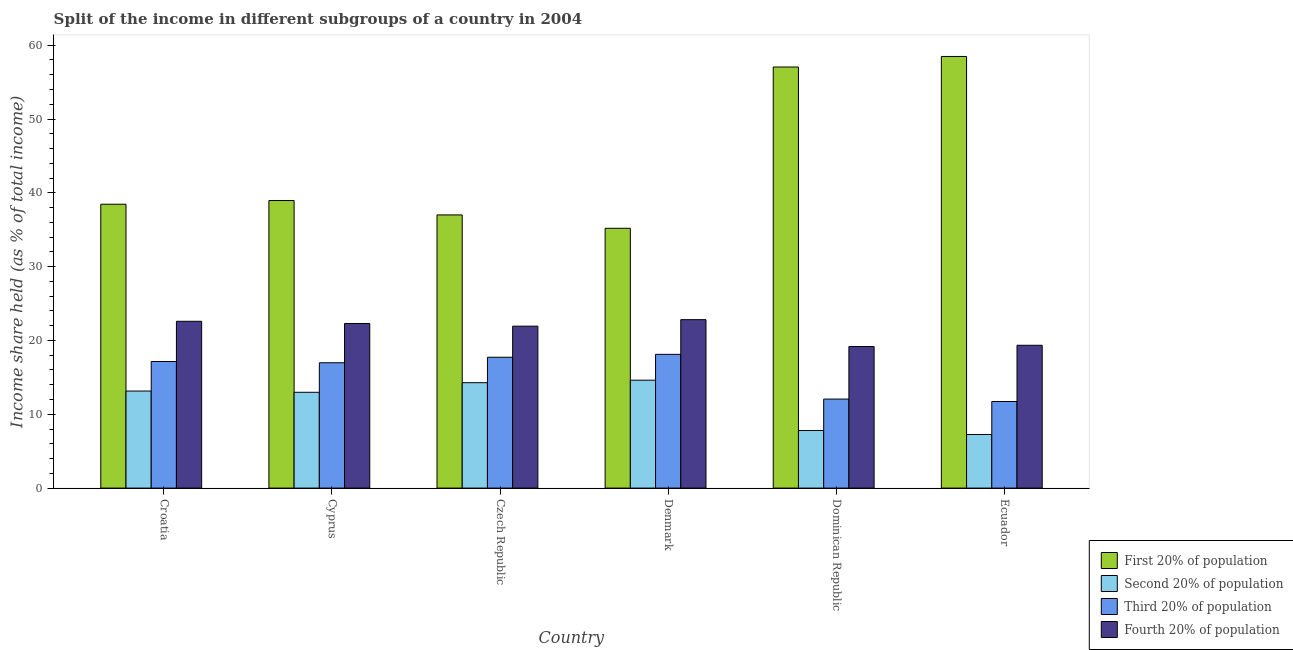How many different coloured bars are there?
Provide a short and direct response. 4. Are the number of bars on each tick of the X-axis equal?
Give a very brief answer. Yes. How many bars are there on the 1st tick from the left?
Make the answer very short. 4. What is the label of the 5th group of bars from the left?
Offer a terse response. Dominican Republic. In how many cases, is the number of bars for a given country not equal to the number of legend labels?
Give a very brief answer. 0. What is the share of the income held by fourth 20% of the population in Dominican Republic?
Ensure brevity in your answer.  19.18. Across all countries, what is the maximum share of the income held by first 20% of the population?
Offer a very short reply. 58.48. Across all countries, what is the minimum share of the income held by fourth 20% of the population?
Keep it short and to the point. 19.18. In which country was the share of the income held by second 20% of the population minimum?
Keep it short and to the point. Ecuador. What is the total share of the income held by second 20% of the population in the graph?
Offer a terse response. 70.09. What is the difference between the share of the income held by third 20% of the population in Denmark and the share of the income held by second 20% of the population in Ecuador?
Offer a very short reply. 10.86. What is the average share of the income held by third 20% of the population per country?
Keep it short and to the point. 15.63. What is the difference between the share of the income held by third 20% of the population and share of the income held by first 20% of the population in Denmark?
Ensure brevity in your answer.  -17.08. What is the ratio of the share of the income held by second 20% of the population in Dominican Republic to that in Ecuador?
Make the answer very short. 1.07. Is the share of the income held by second 20% of the population in Croatia less than that in Dominican Republic?
Provide a short and direct response. No. Is the difference between the share of the income held by third 20% of the population in Cyprus and Denmark greater than the difference between the share of the income held by second 20% of the population in Cyprus and Denmark?
Offer a very short reply. Yes. What is the difference between the highest and the second highest share of the income held by second 20% of the population?
Provide a short and direct response. 0.34. What is the difference between the highest and the lowest share of the income held by first 20% of the population?
Your response must be concise. 23.28. Is the sum of the share of the income held by second 20% of the population in Czech Republic and Dominican Republic greater than the maximum share of the income held by fourth 20% of the population across all countries?
Your answer should be very brief. No. What does the 3rd bar from the left in Croatia represents?
Ensure brevity in your answer.  Third 20% of population. What does the 2nd bar from the right in Dominican Republic represents?
Your answer should be compact. Third 20% of population. Is it the case that in every country, the sum of the share of the income held by first 20% of the population and share of the income held by second 20% of the population is greater than the share of the income held by third 20% of the population?
Your response must be concise. Yes. How many bars are there?
Your answer should be compact. 24. Are all the bars in the graph horizontal?
Make the answer very short. No. How many countries are there in the graph?
Make the answer very short. 6. What is the difference between two consecutive major ticks on the Y-axis?
Your response must be concise. 10. Are the values on the major ticks of Y-axis written in scientific E-notation?
Provide a succinct answer. No. Does the graph contain any zero values?
Ensure brevity in your answer.  No. Where does the legend appear in the graph?
Give a very brief answer. Bottom right. How many legend labels are there?
Make the answer very short. 4. What is the title of the graph?
Provide a short and direct response. Split of the income in different subgroups of a country in 2004. What is the label or title of the Y-axis?
Your response must be concise. Income share held (as % of total income). What is the Income share held (as % of total income) in First 20% of population in Croatia?
Make the answer very short. 38.46. What is the Income share held (as % of total income) in Second 20% of population in Croatia?
Ensure brevity in your answer.  13.15. What is the Income share held (as % of total income) of Third 20% of population in Croatia?
Offer a terse response. 17.15. What is the Income share held (as % of total income) in Fourth 20% of population in Croatia?
Make the answer very short. 22.6. What is the Income share held (as % of total income) in First 20% of population in Cyprus?
Your answer should be very brief. 38.96. What is the Income share held (as % of total income) in Second 20% of population in Cyprus?
Make the answer very short. 12.98. What is the Income share held (as % of total income) in Third 20% of population in Cyprus?
Keep it short and to the point. 16.98. What is the Income share held (as % of total income) of Fourth 20% of population in Cyprus?
Provide a short and direct response. 22.3. What is the Income share held (as % of total income) of First 20% of population in Czech Republic?
Make the answer very short. 37.01. What is the Income share held (as % of total income) in Second 20% of population in Czech Republic?
Provide a short and direct response. 14.28. What is the Income share held (as % of total income) of Third 20% of population in Czech Republic?
Keep it short and to the point. 17.73. What is the Income share held (as % of total income) of Fourth 20% of population in Czech Republic?
Keep it short and to the point. 21.94. What is the Income share held (as % of total income) of First 20% of population in Denmark?
Ensure brevity in your answer.  35.2. What is the Income share held (as % of total income) in Second 20% of population in Denmark?
Make the answer very short. 14.62. What is the Income share held (as % of total income) in Third 20% of population in Denmark?
Provide a short and direct response. 18.12. What is the Income share held (as % of total income) of Fourth 20% of population in Denmark?
Give a very brief answer. 22.82. What is the Income share held (as % of total income) of First 20% of population in Dominican Republic?
Your answer should be very brief. 57.05. What is the Income share held (as % of total income) of Second 20% of population in Dominican Republic?
Give a very brief answer. 7.8. What is the Income share held (as % of total income) in Third 20% of population in Dominican Republic?
Provide a succinct answer. 12.06. What is the Income share held (as % of total income) in Fourth 20% of population in Dominican Republic?
Your answer should be very brief. 19.18. What is the Income share held (as % of total income) in First 20% of population in Ecuador?
Provide a succinct answer. 58.48. What is the Income share held (as % of total income) of Second 20% of population in Ecuador?
Offer a terse response. 7.26. What is the Income share held (as % of total income) in Third 20% of population in Ecuador?
Give a very brief answer. 11.73. What is the Income share held (as % of total income) of Fourth 20% of population in Ecuador?
Offer a very short reply. 19.35. Across all countries, what is the maximum Income share held (as % of total income) of First 20% of population?
Ensure brevity in your answer.  58.48. Across all countries, what is the maximum Income share held (as % of total income) of Second 20% of population?
Offer a terse response. 14.62. Across all countries, what is the maximum Income share held (as % of total income) of Third 20% of population?
Provide a succinct answer. 18.12. Across all countries, what is the maximum Income share held (as % of total income) in Fourth 20% of population?
Give a very brief answer. 22.82. Across all countries, what is the minimum Income share held (as % of total income) of First 20% of population?
Your response must be concise. 35.2. Across all countries, what is the minimum Income share held (as % of total income) of Second 20% of population?
Ensure brevity in your answer.  7.26. Across all countries, what is the minimum Income share held (as % of total income) of Third 20% of population?
Provide a succinct answer. 11.73. Across all countries, what is the minimum Income share held (as % of total income) of Fourth 20% of population?
Give a very brief answer. 19.18. What is the total Income share held (as % of total income) in First 20% of population in the graph?
Your response must be concise. 265.16. What is the total Income share held (as % of total income) of Second 20% of population in the graph?
Make the answer very short. 70.09. What is the total Income share held (as % of total income) of Third 20% of population in the graph?
Your answer should be very brief. 93.77. What is the total Income share held (as % of total income) of Fourth 20% of population in the graph?
Keep it short and to the point. 128.19. What is the difference between the Income share held (as % of total income) in Second 20% of population in Croatia and that in Cyprus?
Offer a very short reply. 0.17. What is the difference between the Income share held (as % of total income) in Third 20% of population in Croatia and that in Cyprus?
Your answer should be compact. 0.17. What is the difference between the Income share held (as % of total income) of Fourth 20% of population in Croatia and that in Cyprus?
Keep it short and to the point. 0.3. What is the difference between the Income share held (as % of total income) of First 20% of population in Croatia and that in Czech Republic?
Give a very brief answer. 1.45. What is the difference between the Income share held (as % of total income) in Second 20% of population in Croatia and that in Czech Republic?
Offer a very short reply. -1.13. What is the difference between the Income share held (as % of total income) in Third 20% of population in Croatia and that in Czech Republic?
Provide a short and direct response. -0.58. What is the difference between the Income share held (as % of total income) of Fourth 20% of population in Croatia and that in Czech Republic?
Make the answer very short. 0.66. What is the difference between the Income share held (as % of total income) of First 20% of population in Croatia and that in Denmark?
Ensure brevity in your answer.  3.26. What is the difference between the Income share held (as % of total income) in Second 20% of population in Croatia and that in Denmark?
Keep it short and to the point. -1.47. What is the difference between the Income share held (as % of total income) of Third 20% of population in Croatia and that in Denmark?
Keep it short and to the point. -0.97. What is the difference between the Income share held (as % of total income) in Fourth 20% of population in Croatia and that in Denmark?
Your answer should be compact. -0.22. What is the difference between the Income share held (as % of total income) in First 20% of population in Croatia and that in Dominican Republic?
Ensure brevity in your answer.  -18.59. What is the difference between the Income share held (as % of total income) in Second 20% of population in Croatia and that in Dominican Republic?
Offer a terse response. 5.35. What is the difference between the Income share held (as % of total income) in Third 20% of population in Croatia and that in Dominican Republic?
Make the answer very short. 5.09. What is the difference between the Income share held (as % of total income) of Fourth 20% of population in Croatia and that in Dominican Republic?
Ensure brevity in your answer.  3.42. What is the difference between the Income share held (as % of total income) of First 20% of population in Croatia and that in Ecuador?
Keep it short and to the point. -20.02. What is the difference between the Income share held (as % of total income) in Second 20% of population in Croatia and that in Ecuador?
Make the answer very short. 5.89. What is the difference between the Income share held (as % of total income) of Third 20% of population in Croatia and that in Ecuador?
Ensure brevity in your answer.  5.42. What is the difference between the Income share held (as % of total income) in First 20% of population in Cyprus and that in Czech Republic?
Your answer should be compact. 1.95. What is the difference between the Income share held (as % of total income) in Third 20% of population in Cyprus and that in Czech Republic?
Your answer should be compact. -0.75. What is the difference between the Income share held (as % of total income) in Fourth 20% of population in Cyprus and that in Czech Republic?
Provide a short and direct response. 0.36. What is the difference between the Income share held (as % of total income) in First 20% of population in Cyprus and that in Denmark?
Offer a very short reply. 3.76. What is the difference between the Income share held (as % of total income) in Second 20% of population in Cyprus and that in Denmark?
Your answer should be compact. -1.64. What is the difference between the Income share held (as % of total income) of Third 20% of population in Cyprus and that in Denmark?
Offer a terse response. -1.14. What is the difference between the Income share held (as % of total income) in Fourth 20% of population in Cyprus and that in Denmark?
Make the answer very short. -0.52. What is the difference between the Income share held (as % of total income) in First 20% of population in Cyprus and that in Dominican Republic?
Make the answer very short. -18.09. What is the difference between the Income share held (as % of total income) of Second 20% of population in Cyprus and that in Dominican Republic?
Ensure brevity in your answer.  5.18. What is the difference between the Income share held (as % of total income) in Third 20% of population in Cyprus and that in Dominican Republic?
Give a very brief answer. 4.92. What is the difference between the Income share held (as % of total income) in Fourth 20% of population in Cyprus and that in Dominican Republic?
Provide a short and direct response. 3.12. What is the difference between the Income share held (as % of total income) in First 20% of population in Cyprus and that in Ecuador?
Ensure brevity in your answer.  -19.52. What is the difference between the Income share held (as % of total income) in Second 20% of population in Cyprus and that in Ecuador?
Offer a terse response. 5.72. What is the difference between the Income share held (as % of total income) of Third 20% of population in Cyprus and that in Ecuador?
Give a very brief answer. 5.25. What is the difference between the Income share held (as % of total income) of Fourth 20% of population in Cyprus and that in Ecuador?
Make the answer very short. 2.95. What is the difference between the Income share held (as % of total income) in First 20% of population in Czech Republic and that in Denmark?
Provide a short and direct response. 1.81. What is the difference between the Income share held (as % of total income) in Second 20% of population in Czech Republic and that in Denmark?
Give a very brief answer. -0.34. What is the difference between the Income share held (as % of total income) in Third 20% of population in Czech Republic and that in Denmark?
Your answer should be very brief. -0.39. What is the difference between the Income share held (as % of total income) in Fourth 20% of population in Czech Republic and that in Denmark?
Offer a very short reply. -0.88. What is the difference between the Income share held (as % of total income) in First 20% of population in Czech Republic and that in Dominican Republic?
Make the answer very short. -20.04. What is the difference between the Income share held (as % of total income) of Second 20% of population in Czech Republic and that in Dominican Republic?
Your answer should be compact. 6.48. What is the difference between the Income share held (as % of total income) of Third 20% of population in Czech Republic and that in Dominican Republic?
Your answer should be very brief. 5.67. What is the difference between the Income share held (as % of total income) in Fourth 20% of population in Czech Republic and that in Dominican Republic?
Your response must be concise. 2.76. What is the difference between the Income share held (as % of total income) of First 20% of population in Czech Republic and that in Ecuador?
Provide a succinct answer. -21.47. What is the difference between the Income share held (as % of total income) in Second 20% of population in Czech Republic and that in Ecuador?
Make the answer very short. 7.02. What is the difference between the Income share held (as % of total income) in Fourth 20% of population in Czech Republic and that in Ecuador?
Provide a short and direct response. 2.59. What is the difference between the Income share held (as % of total income) of First 20% of population in Denmark and that in Dominican Republic?
Your answer should be compact. -21.85. What is the difference between the Income share held (as % of total income) of Second 20% of population in Denmark and that in Dominican Republic?
Your response must be concise. 6.82. What is the difference between the Income share held (as % of total income) in Third 20% of population in Denmark and that in Dominican Republic?
Keep it short and to the point. 6.06. What is the difference between the Income share held (as % of total income) in Fourth 20% of population in Denmark and that in Dominican Republic?
Provide a short and direct response. 3.64. What is the difference between the Income share held (as % of total income) of First 20% of population in Denmark and that in Ecuador?
Provide a succinct answer. -23.28. What is the difference between the Income share held (as % of total income) of Second 20% of population in Denmark and that in Ecuador?
Give a very brief answer. 7.36. What is the difference between the Income share held (as % of total income) of Third 20% of population in Denmark and that in Ecuador?
Your response must be concise. 6.39. What is the difference between the Income share held (as % of total income) of Fourth 20% of population in Denmark and that in Ecuador?
Provide a succinct answer. 3.47. What is the difference between the Income share held (as % of total income) in First 20% of population in Dominican Republic and that in Ecuador?
Your answer should be compact. -1.43. What is the difference between the Income share held (as % of total income) of Second 20% of population in Dominican Republic and that in Ecuador?
Your response must be concise. 0.54. What is the difference between the Income share held (as % of total income) in Third 20% of population in Dominican Republic and that in Ecuador?
Ensure brevity in your answer.  0.33. What is the difference between the Income share held (as % of total income) in Fourth 20% of population in Dominican Republic and that in Ecuador?
Provide a short and direct response. -0.17. What is the difference between the Income share held (as % of total income) in First 20% of population in Croatia and the Income share held (as % of total income) in Second 20% of population in Cyprus?
Keep it short and to the point. 25.48. What is the difference between the Income share held (as % of total income) in First 20% of population in Croatia and the Income share held (as % of total income) in Third 20% of population in Cyprus?
Your answer should be very brief. 21.48. What is the difference between the Income share held (as % of total income) of First 20% of population in Croatia and the Income share held (as % of total income) of Fourth 20% of population in Cyprus?
Your answer should be compact. 16.16. What is the difference between the Income share held (as % of total income) of Second 20% of population in Croatia and the Income share held (as % of total income) of Third 20% of population in Cyprus?
Provide a succinct answer. -3.83. What is the difference between the Income share held (as % of total income) of Second 20% of population in Croatia and the Income share held (as % of total income) of Fourth 20% of population in Cyprus?
Provide a succinct answer. -9.15. What is the difference between the Income share held (as % of total income) of Third 20% of population in Croatia and the Income share held (as % of total income) of Fourth 20% of population in Cyprus?
Your answer should be very brief. -5.15. What is the difference between the Income share held (as % of total income) in First 20% of population in Croatia and the Income share held (as % of total income) in Second 20% of population in Czech Republic?
Offer a very short reply. 24.18. What is the difference between the Income share held (as % of total income) of First 20% of population in Croatia and the Income share held (as % of total income) of Third 20% of population in Czech Republic?
Your answer should be compact. 20.73. What is the difference between the Income share held (as % of total income) in First 20% of population in Croatia and the Income share held (as % of total income) in Fourth 20% of population in Czech Republic?
Make the answer very short. 16.52. What is the difference between the Income share held (as % of total income) in Second 20% of population in Croatia and the Income share held (as % of total income) in Third 20% of population in Czech Republic?
Keep it short and to the point. -4.58. What is the difference between the Income share held (as % of total income) in Second 20% of population in Croatia and the Income share held (as % of total income) in Fourth 20% of population in Czech Republic?
Offer a very short reply. -8.79. What is the difference between the Income share held (as % of total income) of Third 20% of population in Croatia and the Income share held (as % of total income) of Fourth 20% of population in Czech Republic?
Ensure brevity in your answer.  -4.79. What is the difference between the Income share held (as % of total income) of First 20% of population in Croatia and the Income share held (as % of total income) of Second 20% of population in Denmark?
Make the answer very short. 23.84. What is the difference between the Income share held (as % of total income) of First 20% of population in Croatia and the Income share held (as % of total income) of Third 20% of population in Denmark?
Your answer should be very brief. 20.34. What is the difference between the Income share held (as % of total income) in First 20% of population in Croatia and the Income share held (as % of total income) in Fourth 20% of population in Denmark?
Ensure brevity in your answer.  15.64. What is the difference between the Income share held (as % of total income) of Second 20% of population in Croatia and the Income share held (as % of total income) of Third 20% of population in Denmark?
Provide a short and direct response. -4.97. What is the difference between the Income share held (as % of total income) of Second 20% of population in Croatia and the Income share held (as % of total income) of Fourth 20% of population in Denmark?
Your answer should be compact. -9.67. What is the difference between the Income share held (as % of total income) in Third 20% of population in Croatia and the Income share held (as % of total income) in Fourth 20% of population in Denmark?
Your answer should be compact. -5.67. What is the difference between the Income share held (as % of total income) in First 20% of population in Croatia and the Income share held (as % of total income) in Second 20% of population in Dominican Republic?
Provide a short and direct response. 30.66. What is the difference between the Income share held (as % of total income) of First 20% of population in Croatia and the Income share held (as % of total income) of Third 20% of population in Dominican Republic?
Offer a terse response. 26.4. What is the difference between the Income share held (as % of total income) of First 20% of population in Croatia and the Income share held (as % of total income) of Fourth 20% of population in Dominican Republic?
Give a very brief answer. 19.28. What is the difference between the Income share held (as % of total income) in Second 20% of population in Croatia and the Income share held (as % of total income) in Third 20% of population in Dominican Republic?
Your answer should be very brief. 1.09. What is the difference between the Income share held (as % of total income) in Second 20% of population in Croatia and the Income share held (as % of total income) in Fourth 20% of population in Dominican Republic?
Keep it short and to the point. -6.03. What is the difference between the Income share held (as % of total income) of Third 20% of population in Croatia and the Income share held (as % of total income) of Fourth 20% of population in Dominican Republic?
Make the answer very short. -2.03. What is the difference between the Income share held (as % of total income) of First 20% of population in Croatia and the Income share held (as % of total income) of Second 20% of population in Ecuador?
Make the answer very short. 31.2. What is the difference between the Income share held (as % of total income) of First 20% of population in Croatia and the Income share held (as % of total income) of Third 20% of population in Ecuador?
Your answer should be compact. 26.73. What is the difference between the Income share held (as % of total income) in First 20% of population in Croatia and the Income share held (as % of total income) in Fourth 20% of population in Ecuador?
Your answer should be very brief. 19.11. What is the difference between the Income share held (as % of total income) of Second 20% of population in Croatia and the Income share held (as % of total income) of Third 20% of population in Ecuador?
Make the answer very short. 1.42. What is the difference between the Income share held (as % of total income) of Second 20% of population in Croatia and the Income share held (as % of total income) of Fourth 20% of population in Ecuador?
Provide a succinct answer. -6.2. What is the difference between the Income share held (as % of total income) in Third 20% of population in Croatia and the Income share held (as % of total income) in Fourth 20% of population in Ecuador?
Provide a short and direct response. -2.2. What is the difference between the Income share held (as % of total income) in First 20% of population in Cyprus and the Income share held (as % of total income) in Second 20% of population in Czech Republic?
Offer a terse response. 24.68. What is the difference between the Income share held (as % of total income) of First 20% of population in Cyprus and the Income share held (as % of total income) of Third 20% of population in Czech Republic?
Offer a very short reply. 21.23. What is the difference between the Income share held (as % of total income) in First 20% of population in Cyprus and the Income share held (as % of total income) in Fourth 20% of population in Czech Republic?
Provide a short and direct response. 17.02. What is the difference between the Income share held (as % of total income) in Second 20% of population in Cyprus and the Income share held (as % of total income) in Third 20% of population in Czech Republic?
Ensure brevity in your answer.  -4.75. What is the difference between the Income share held (as % of total income) of Second 20% of population in Cyprus and the Income share held (as % of total income) of Fourth 20% of population in Czech Republic?
Ensure brevity in your answer.  -8.96. What is the difference between the Income share held (as % of total income) in Third 20% of population in Cyprus and the Income share held (as % of total income) in Fourth 20% of population in Czech Republic?
Provide a short and direct response. -4.96. What is the difference between the Income share held (as % of total income) in First 20% of population in Cyprus and the Income share held (as % of total income) in Second 20% of population in Denmark?
Ensure brevity in your answer.  24.34. What is the difference between the Income share held (as % of total income) of First 20% of population in Cyprus and the Income share held (as % of total income) of Third 20% of population in Denmark?
Provide a short and direct response. 20.84. What is the difference between the Income share held (as % of total income) in First 20% of population in Cyprus and the Income share held (as % of total income) in Fourth 20% of population in Denmark?
Keep it short and to the point. 16.14. What is the difference between the Income share held (as % of total income) of Second 20% of population in Cyprus and the Income share held (as % of total income) of Third 20% of population in Denmark?
Offer a very short reply. -5.14. What is the difference between the Income share held (as % of total income) of Second 20% of population in Cyprus and the Income share held (as % of total income) of Fourth 20% of population in Denmark?
Offer a terse response. -9.84. What is the difference between the Income share held (as % of total income) in Third 20% of population in Cyprus and the Income share held (as % of total income) in Fourth 20% of population in Denmark?
Your answer should be compact. -5.84. What is the difference between the Income share held (as % of total income) of First 20% of population in Cyprus and the Income share held (as % of total income) of Second 20% of population in Dominican Republic?
Your response must be concise. 31.16. What is the difference between the Income share held (as % of total income) of First 20% of population in Cyprus and the Income share held (as % of total income) of Third 20% of population in Dominican Republic?
Offer a very short reply. 26.9. What is the difference between the Income share held (as % of total income) in First 20% of population in Cyprus and the Income share held (as % of total income) in Fourth 20% of population in Dominican Republic?
Provide a succinct answer. 19.78. What is the difference between the Income share held (as % of total income) in Third 20% of population in Cyprus and the Income share held (as % of total income) in Fourth 20% of population in Dominican Republic?
Your response must be concise. -2.2. What is the difference between the Income share held (as % of total income) in First 20% of population in Cyprus and the Income share held (as % of total income) in Second 20% of population in Ecuador?
Your response must be concise. 31.7. What is the difference between the Income share held (as % of total income) in First 20% of population in Cyprus and the Income share held (as % of total income) in Third 20% of population in Ecuador?
Keep it short and to the point. 27.23. What is the difference between the Income share held (as % of total income) in First 20% of population in Cyprus and the Income share held (as % of total income) in Fourth 20% of population in Ecuador?
Ensure brevity in your answer.  19.61. What is the difference between the Income share held (as % of total income) in Second 20% of population in Cyprus and the Income share held (as % of total income) in Third 20% of population in Ecuador?
Keep it short and to the point. 1.25. What is the difference between the Income share held (as % of total income) in Second 20% of population in Cyprus and the Income share held (as % of total income) in Fourth 20% of population in Ecuador?
Provide a succinct answer. -6.37. What is the difference between the Income share held (as % of total income) of Third 20% of population in Cyprus and the Income share held (as % of total income) of Fourth 20% of population in Ecuador?
Give a very brief answer. -2.37. What is the difference between the Income share held (as % of total income) of First 20% of population in Czech Republic and the Income share held (as % of total income) of Second 20% of population in Denmark?
Offer a very short reply. 22.39. What is the difference between the Income share held (as % of total income) in First 20% of population in Czech Republic and the Income share held (as % of total income) in Third 20% of population in Denmark?
Make the answer very short. 18.89. What is the difference between the Income share held (as % of total income) of First 20% of population in Czech Republic and the Income share held (as % of total income) of Fourth 20% of population in Denmark?
Provide a succinct answer. 14.19. What is the difference between the Income share held (as % of total income) in Second 20% of population in Czech Republic and the Income share held (as % of total income) in Third 20% of population in Denmark?
Your answer should be compact. -3.84. What is the difference between the Income share held (as % of total income) in Second 20% of population in Czech Republic and the Income share held (as % of total income) in Fourth 20% of population in Denmark?
Offer a very short reply. -8.54. What is the difference between the Income share held (as % of total income) of Third 20% of population in Czech Republic and the Income share held (as % of total income) of Fourth 20% of population in Denmark?
Your answer should be compact. -5.09. What is the difference between the Income share held (as % of total income) of First 20% of population in Czech Republic and the Income share held (as % of total income) of Second 20% of population in Dominican Republic?
Make the answer very short. 29.21. What is the difference between the Income share held (as % of total income) in First 20% of population in Czech Republic and the Income share held (as % of total income) in Third 20% of population in Dominican Republic?
Keep it short and to the point. 24.95. What is the difference between the Income share held (as % of total income) of First 20% of population in Czech Republic and the Income share held (as % of total income) of Fourth 20% of population in Dominican Republic?
Keep it short and to the point. 17.83. What is the difference between the Income share held (as % of total income) in Second 20% of population in Czech Republic and the Income share held (as % of total income) in Third 20% of population in Dominican Republic?
Make the answer very short. 2.22. What is the difference between the Income share held (as % of total income) of Third 20% of population in Czech Republic and the Income share held (as % of total income) of Fourth 20% of population in Dominican Republic?
Offer a very short reply. -1.45. What is the difference between the Income share held (as % of total income) of First 20% of population in Czech Republic and the Income share held (as % of total income) of Second 20% of population in Ecuador?
Your answer should be very brief. 29.75. What is the difference between the Income share held (as % of total income) in First 20% of population in Czech Republic and the Income share held (as % of total income) in Third 20% of population in Ecuador?
Offer a terse response. 25.28. What is the difference between the Income share held (as % of total income) in First 20% of population in Czech Republic and the Income share held (as % of total income) in Fourth 20% of population in Ecuador?
Ensure brevity in your answer.  17.66. What is the difference between the Income share held (as % of total income) of Second 20% of population in Czech Republic and the Income share held (as % of total income) of Third 20% of population in Ecuador?
Ensure brevity in your answer.  2.55. What is the difference between the Income share held (as % of total income) in Second 20% of population in Czech Republic and the Income share held (as % of total income) in Fourth 20% of population in Ecuador?
Give a very brief answer. -5.07. What is the difference between the Income share held (as % of total income) of Third 20% of population in Czech Republic and the Income share held (as % of total income) of Fourth 20% of population in Ecuador?
Offer a terse response. -1.62. What is the difference between the Income share held (as % of total income) of First 20% of population in Denmark and the Income share held (as % of total income) of Second 20% of population in Dominican Republic?
Make the answer very short. 27.4. What is the difference between the Income share held (as % of total income) in First 20% of population in Denmark and the Income share held (as % of total income) in Third 20% of population in Dominican Republic?
Your response must be concise. 23.14. What is the difference between the Income share held (as % of total income) of First 20% of population in Denmark and the Income share held (as % of total income) of Fourth 20% of population in Dominican Republic?
Keep it short and to the point. 16.02. What is the difference between the Income share held (as % of total income) in Second 20% of population in Denmark and the Income share held (as % of total income) in Third 20% of population in Dominican Republic?
Your answer should be compact. 2.56. What is the difference between the Income share held (as % of total income) in Second 20% of population in Denmark and the Income share held (as % of total income) in Fourth 20% of population in Dominican Republic?
Provide a succinct answer. -4.56. What is the difference between the Income share held (as % of total income) of Third 20% of population in Denmark and the Income share held (as % of total income) of Fourth 20% of population in Dominican Republic?
Offer a very short reply. -1.06. What is the difference between the Income share held (as % of total income) of First 20% of population in Denmark and the Income share held (as % of total income) of Second 20% of population in Ecuador?
Make the answer very short. 27.94. What is the difference between the Income share held (as % of total income) in First 20% of population in Denmark and the Income share held (as % of total income) in Third 20% of population in Ecuador?
Offer a very short reply. 23.47. What is the difference between the Income share held (as % of total income) in First 20% of population in Denmark and the Income share held (as % of total income) in Fourth 20% of population in Ecuador?
Keep it short and to the point. 15.85. What is the difference between the Income share held (as % of total income) in Second 20% of population in Denmark and the Income share held (as % of total income) in Third 20% of population in Ecuador?
Make the answer very short. 2.89. What is the difference between the Income share held (as % of total income) in Second 20% of population in Denmark and the Income share held (as % of total income) in Fourth 20% of population in Ecuador?
Offer a terse response. -4.73. What is the difference between the Income share held (as % of total income) of Third 20% of population in Denmark and the Income share held (as % of total income) of Fourth 20% of population in Ecuador?
Your answer should be compact. -1.23. What is the difference between the Income share held (as % of total income) in First 20% of population in Dominican Republic and the Income share held (as % of total income) in Second 20% of population in Ecuador?
Give a very brief answer. 49.79. What is the difference between the Income share held (as % of total income) of First 20% of population in Dominican Republic and the Income share held (as % of total income) of Third 20% of population in Ecuador?
Your answer should be very brief. 45.32. What is the difference between the Income share held (as % of total income) in First 20% of population in Dominican Republic and the Income share held (as % of total income) in Fourth 20% of population in Ecuador?
Give a very brief answer. 37.7. What is the difference between the Income share held (as % of total income) in Second 20% of population in Dominican Republic and the Income share held (as % of total income) in Third 20% of population in Ecuador?
Make the answer very short. -3.93. What is the difference between the Income share held (as % of total income) in Second 20% of population in Dominican Republic and the Income share held (as % of total income) in Fourth 20% of population in Ecuador?
Your answer should be very brief. -11.55. What is the difference between the Income share held (as % of total income) of Third 20% of population in Dominican Republic and the Income share held (as % of total income) of Fourth 20% of population in Ecuador?
Provide a succinct answer. -7.29. What is the average Income share held (as % of total income) of First 20% of population per country?
Offer a terse response. 44.19. What is the average Income share held (as % of total income) in Second 20% of population per country?
Offer a very short reply. 11.68. What is the average Income share held (as % of total income) of Third 20% of population per country?
Your answer should be compact. 15.63. What is the average Income share held (as % of total income) of Fourth 20% of population per country?
Keep it short and to the point. 21.36. What is the difference between the Income share held (as % of total income) in First 20% of population and Income share held (as % of total income) in Second 20% of population in Croatia?
Provide a short and direct response. 25.31. What is the difference between the Income share held (as % of total income) of First 20% of population and Income share held (as % of total income) of Third 20% of population in Croatia?
Your answer should be compact. 21.31. What is the difference between the Income share held (as % of total income) in First 20% of population and Income share held (as % of total income) in Fourth 20% of population in Croatia?
Offer a very short reply. 15.86. What is the difference between the Income share held (as % of total income) in Second 20% of population and Income share held (as % of total income) in Fourth 20% of population in Croatia?
Keep it short and to the point. -9.45. What is the difference between the Income share held (as % of total income) in Third 20% of population and Income share held (as % of total income) in Fourth 20% of population in Croatia?
Your answer should be compact. -5.45. What is the difference between the Income share held (as % of total income) in First 20% of population and Income share held (as % of total income) in Second 20% of population in Cyprus?
Provide a succinct answer. 25.98. What is the difference between the Income share held (as % of total income) of First 20% of population and Income share held (as % of total income) of Third 20% of population in Cyprus?
Make the answer very short. 21.98. What is the difference between the Income share held (as % of total income) in First 20% of population and Income share held (as % of total income) in Fourth 20% of population in Cyprus?
Your response must be concise. 16.66. What is the difference between the Income share held (as % of total income) in Second 20% of population and Income share held (as % of total income) in Third 20% of population in Cyprus?
Give a very brief answer. -4. What is the difference between the Income share held (as % of total income) of Second 20% of population and Income share held (as % of total income) of Fourth 20% of population in Cyprus?
Provide a short and direct response. -9.32. What is the difference between the Income share held (as % of total income) in Third 20% of population and Income share held (as % of total income) in Fourth 20% of population in Cyprus?
Your answer should be very brief. -5.32. What is the difference between the Income share held (as % of total income) in First 20% of population and Income share held (as % of total income) in Second 20% of population in Czech Republic?
Your answer should be compact. 22.73. What is the difference between the Income share held (as % of total income) in First 20% of population and Income share held (as % of total income) in Third 20% of population in Czech Republic?
Keep it short and to the point. 19.28. What is the difference between the Income share held (as % of total income) in First 20% of population and Income share held (as % of total income) in Fourth 20% of population in Czech Republic?
Provide a short and direct response. 15.07. What is the difference between the Income share held (as % of total income) of Second 20% of population and Income share held (as % of total income) of Third 20% of population in Czech Republic?
Provide a short and direct response. -3.45. What is the difference between the Income share held (as % of total income) of Second 20% of population and Income share held (as % of total income) of Fourth 20% of population in Czech Republic?
Keep it short and to the point. -7.66. What is the difference between the Income share held (as % of total income) of Third 20% of population and Income share held (as % of total income) of Fourth 20% of population in Czech Republic?
Keep it short and to the point. -4.21. What is the difference between the Income share held (as % of total income) of First 20% of population and Income share held (as % of total income) of Second 20% of population in Denmark?
Provide a short and direct response. 20.58. What is the difference between the Income share held (as % of total income) of First 20% of population and Income share held (as % of total income) of Third 20% of population in Denmark?
Offer a terse response. 17.08. What is the difference between the Income share held (as % of total income) in First 20% of population and Income share held (as % of total income) in Fourth 20% of population in Denmark?
Your response must be concise. 12.38. What is the difference between the Income share held (as % of total income) in Second 20% of population and Income share held (as % of total income) in Third 20% of population in Denmark?
Your answer should be very brief. -3.5. What is the difference between the Income share held (as % of total income) in Second 20% of population and Income share held (as % of total income) in Fourth 20% of population in Denmark?
Provide a short and direct response. -8.2. What is the difference between the Income share held (as % of total income) in Third 20% of population and Income share held (as % of total income) in Fourth 20% of population in Denmark?
Offer a very short reply. -4.7. What is the difference between the Income share held (as % of total income) of First 20% of population and Income share held (as % of total income) of Second 20% of population in Dominican Republic?
Provide a succinct answer. 49.25. What is the difference between the Income share held (as % of total income) of First 20% of population and Income share held (as % of total income) of Third 20% of population in Dominican Republic?
Keep it short and to the point. 44.99. What is the difference between the Income share held (as % of total income) of First 20% of population and Income share held (as % of total income) of Fourth 20% of population in Dominican Republic?
Give a very brief answer. 37.87. What is the difference between the Income share held (as % of total income) of Second 20% of population and Income share held (as % of total income) of Third 20% of population in Dominican Republic?
Keep it short and to the point. -4.26. What is the difference between the Income share held (as % of total income) in Second 20% of population and Income share held (as % of total income) in Fourth 20% of population in Dominican Republic?
Make the answer very short. -11.38. What is the difference between the Income share held (as % of total income) of Third 20% of population and Income share held (as % of total income) of Fourth 20% of population in Dominican Republic?
Provide a succinct answer. -7.12. What is the difference between the Income share held (as % of total income) of First 20% of population and Income share held (as % of total income) of Second 20% of population in Ecuador?
Provide a short and direct response. 51.22. What is the difference between the Income share held (as % of total income) in First 20% of population and Income share held (as % of total income) in Third 20% of population in Ecuador?
Keep it short and to the point. 46.75. What is the difference between the Income share held (as % of total income) of First 20% of population and Income share held (as % of total income) of Fourth 20% of population in Ecuador?
Your answer should be compact. 39.13. What is the difference between the Income share held (as % of total income) of Second 20% of population and Income share held (as % of total income) of Third 20% of population in Ecuador?
Your response must be concise. -4.47. What is the difference between the Income share held (as % of total income) in Second 20% of population and Income share held (as % of total income) in Fourth 20% of population in Ecuador?
Your response must be concise. -12.09. What is the difference between the Income share held (as % of total income) in Third 20% of population and Income share held (as % of total income) in Fourth 20% of population in Ecuador?
Make the answer very short. -7.62. What is the ratio of the Income share held (as % of total income) in First 20% of population in Croatia to that in Cyprus?
Give a very brief answer. 0.99. What is the ratio of the Income share held (as % of total income) in Second 20% of population in Croatia to that in Cyprus?
Your response must be concise. 1.01. What is the ratio of the Income share held (as % of total income) of Third 20% of population in Croatia to that in Cyprus?
Keep it short and to the point. 1.01. What is the ratio of the Income share held (as % of total income) of Fourth 20% of population in Croatia to that in Cyprus?
Keep it short and to the point. 1.01. What is the ratio of the Income share held (as % of total income) of First 20% of population in Croatia to that in Czech Republic?
Give a very brief answer. 1.04. What is the ratio of the Income share held (as % of total income) in Second 20% of population in Croatia to that in Czech Republic?
Offer a very short reply. 0.92. What is the ratio of the Income share held (as % of total income) in Third 20% of population in Croatia to that in Czech Republic?
Offer a terse response. 0.97. What is the ratio of the Income share held (as % of total income) of Fourth 20% of population in Croatia to that in Czech Republic?
Provide a short and direct response. 1.03. What is the ratio of the Income share held (as % of total income) of First 20% of population in Croatia to that in Denmark?
Your answer should be compact. 1.09. What is the ratio of the Income share held (as % of total income) of Second 20% of population in Croatia to that in Denmark?
Provide a succinct answer. 0.9. What is the ratio of the Income share held (as % of total income) in Third 20% of population in Croatia to that in Denmark?
Your answer should be compact. 0.95. What is the ratio of the Income share held (as % of total income) in First 20% of population in Croatia to that in Dominican Republic?
Give a very brief answer. 0.67. What is the ratio of the Income share held (as % of total income) of Second 20% of population in Croatia to that in Dominican Republic?
Your answer should be very brief. 1.69. What is the ratio of the Income share held (as % of total income) in Third 20% of population in Croatia to that in Dominican Republic?
Provide a short and direct response. 1.42. What is the ratio of the Income share held (as % of total income) of Fourth 20% of population in Croatia to that in Dominican Republic?
Your answer should be very brief. 1.18. What is the ratio of the Income share held (as % of total income) in First 20% of population in Croatia to that in Ecuador?
Provide a short and direct response. 0.66. What is the ratio of the Income share held (as % of total income) of Second 20% of population in Croatia to that in Ecuador?
Your response must be concise. 1.81. What is the ratio of the Income share held (as % of total income) of Third 20% of population in Croatia to that in Ecuador?
Give a very brief answer. 1.46. What is the ratio of the Income share held (as % of total income) in Fourth 20% of population in Croatia to that in Ecuador?
Your response must be concise. 1.17. What is the ratio of the Income share held (as % of total income) in First 20% of population in Cyprus to that in Czech Republic?
Your answer should be compact. 1.05. What is the ratio of the Income share held (as % of total income) in Second 20% of population in Cyprus to that in Czech Republic?
Offer a terse response. 0.91. What is the ratio of the Income share held (as % of total income) of Third 20% of population in Cyprus to that in Czech Republic?
Provide a succinct answer. 0.96. What is the ratio of the Income share held (as % of total income) in Fourth 20% of population in Cyprus to that in Czech Republic?
Offer a terse response. 1.02. What is the ratio of the Income share held (as % of total income) in First 20% of population in Cyprus to that in Denmark?
Offer a very short reply. 1.11. What is the ratio of the Income share held (as % of total income) in Second 20% of population in Cyprus to that in Denmark?
Provide a succinct answer. 0.89. What is the ratio of the Income share held (as % of total income) of Third 20% of population in Cyprus to that in Denmark?
Your answer should be very brief. 0.94. What is the ratio of the Income share held (as % of total income) in Fourth 20% of population in Cyprus to that in Denmark?
Provide a short and direct response. 0.98. What is the ratio of the Income share held (as % of total income) in First 20% of population in Cyprus to that in Dominican Republic?
Give a very brief answer. 0.68. What is the ratio of the Income share held (as % of total income) in Second 20% of population in Cyprus to that in Dominican Republic?
Keep it short and to the point. 1.66. What is the ratio of the Income share held (as % of total income) in Third 20% of population in Cyprus to that in Dominican Republic?
Provide a succinct answer. 1.41. What is the ratio of the Income share held (as % of total income) of Fourth 20% of population in Cyprus to that in Dominican Republic?
Offer a very short reply. 1.16. What is the ratio of the Income share held (as % of total income) in First 20% of population in Cyprus to that in Ecuador?
Offer a terse response. 0.67. What is the ratio of the Income share held (as % of total income) of Second 20% of population in Cyprus to that in Ecuador?
Provide a short and direct response. 1.79. What is the ratio of the Income share held (as % of total income) of Third 20% of population in Cyprus to that in Ecuador?
Ensure brevity in your answer.  1.45. What is the ratio of the Income share held (as % of total income) in Fourth 20% of population in Cyprus to that in Ecuador?
Ensure brevity in your answer.  1.15. What is the ratio of the Income share held (as % of total income) in First 20% of population in Czech Republic to that in Denmark?
Offer a very short reply. 1.05. What is the ratio of the Income share held (as % of total income) of Second 20% of population in Czech Republic to that in Denmark?
Ensure brevity in your answer.  0.98. What is the ratio of the Income share held (as % of total income) of Third 20% of population in Czech Republic to that in Denmark?
Your response must be concise. 0.98. What is the ratio of the Income share held (as % of total income) in Fourth 20% of population in Czech Republic to that in Denmark?
Offer a very short reply. 0.96. What is the ratio of the Income share held (as % of total income) in First 20% of population in Czech Republic to that in Dominican Republic?
Make the answer very short. 0.65. What is the ratio of the Income share held (as % of total income) of Second 20% of population in Czech Republic to that in Dominican Republic?
Offer a terse response. 1.83. What is the ratio of the Income share held (as % of total income) in Third 20% of population in Czech Republic to that in Dominican Republic?
Offer a very short reply. 1.47. What is the ratio of the Income share held (as % of total income) in Fourth 20% of population in Czech Republic to that in Dominican Republic?
Give a very brief answer. 1.14. What is the ratio of the Income share held (as % of total income) of First 20% of population in Czech Republic to that in Ecuador?
Keep it short and to the point. 0.63. What is the ratio of the Income share held (as % of total income) in Second 20% of population in Czech Republic to that in Ecuador?
Give a very brief answer. 1.97. What is the ratio of the Income share held (as % of total income) of Third 20% of population in Czech Republic to that in Ecuador?
Provide a short and direct response. 1.51. What is the ratio of the Income share held (as % of total income) of Fourth 20% of population in Czech Republic to that in Ecuador?
Offer a very short reply. 1.13. What is the ratio of the Income share held (as % of total income) in First 20% of population in Denmark to that in Dominican Republic?
Your answer should be very brief. 0.62. What is the ratio of the Income share held (as % of total income) in Second 20% of population in Denmark to that in Dominican Republic?
Offer a very short reply. 1.87. What is the ratio of the Income share held (as % of total income) of Third 20% of population in Denmark to that in Dominican Republic?
Your answer should be compact. 1.5. What is the ratio of the Income share held (as % of total income) in Fourth 20% of population in Denmark to that in Dominican Republic?
Provide a succinct answer. 1.19. What is the ratio of the Income share held (as % of total income) in First 20% of population in Denmark to that in Ecuador?
Your answer should be compact. 0.6. What is the ratio of the Income share held (as % of total income) in Second 20% of population in Denmark to that in Ecuador?
Ensure brevity in your answer.  2.01. What is the ratio of the Income share held (as % of total income) of Third 20% of population in Denmark to that in Ecuador?
Provide a short and direct response. 1.54. What is the ratio of the Income share held (as % of total income) of Fourth 20% of population in Denmark to that in Ecuador?
Make the answer very short. 1.18. What is the ratio of the Income share held (as % of total income) in First 20% of population in Dominican Republic to that in Ecuador?
Your response must be concise. 0.98. What is the ratio of the Income share held (as % of total income) in Second 20% of population in Dominican Republic to that in Ecuador?
Your answer should be very brief. 1.07. What is the ratio of the Income share held (as % of total income) of Third 20% of population in Dominican Republic to that in Ecuador?
Ensure brevity in your answer.  1.03. What is the difference between the highest and the second highest Income share held (as % of total income) of First 20% of population?
Keep it short and to the point. 1.43. What is the difference between the highest and the second highest Income share held (as % of total income) in Second 20% of population?
Your answer should be very brief. 0.34. What is the difference between the highest and the second highest Income share held (as % of total income) in Third 20% of population?
Provide a succinct answer. 0.39. What is the difference between the highest and the second highest Income share held (as % of total income) in Fourth 20% of population?
Your answer should be compact. 0.22. What is the difference between the highest and the lowest Income share held (as % of total income) of First 20% of population?
Offer a very short reply. 23.28. What is the difference between the highest and the lowest Income share held (as % of total income) in Second 20% of population?
Provide a short and direct response. 7.36. What is the difference between the highest and the lowest Income share held (as % of total income) in Third 20% of population?
Keep it short and to the point. 6.39. What is the difference between the highest and the lowest Income share held (as % of total income) in Fourth 20% of population?
Your answer should be very brief. 3.64. 